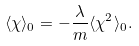<formula> <loc_0><loc_0><loc_500><loc_500>\langle \chi \rangle _ { 0 } = - \frac { \lambda } { m } \langle \chi ^ { 2 } \rangle _ { 0 } .</formula> 